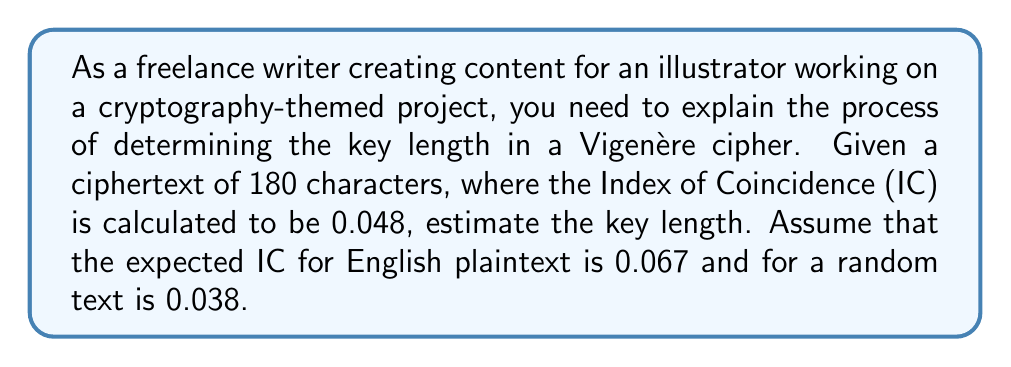Give your solution to this math problem. To estimate the key length of a Vigenère cipher given the Index of Coincidence (IC), we can use the following steps:

1. Let $L$ be the key length we're trying to find.

2. The formula relating IC to key length is:

   $$IC = \frac{1}{L} \cdot IC_{plain} + \frac{L-1}{L} \cdot IC_{random}$$

   Where $IC_{plain}$ is the IC for English plaintext (0.067) and $IC_{random}$ is the IC for random text (0.038).

3. Substitute the known values into the equation:

   $$0.048 = \frac{1}{L} \cdot 0.067 + \frac{L-1}{L} \cdot 0.038$$

4. Multiply both sides by $L$:

   $$0.048L = 0.067 + 0.038(L-1)$$

5. Expand the right side:

   $$0.048L = 0.067 + 0.038L - 0.038$$

6. Simplify:

   $$0.048L = 0.029 + 0.038L$$

7. Subtract $0.038L$ from both sides:

   $$0.01L = 0.029$$

8. Divide both sides by 0.01:

   $$L = \frac{0.029}{0.01} = 2.9$$

9. Since the key length must be an integer, we round to the nearest whole number:

   $$L \approx 3$$

Therefore, the estimated key length for the Vigenère cipher is 3 characters.
Answer: 3 